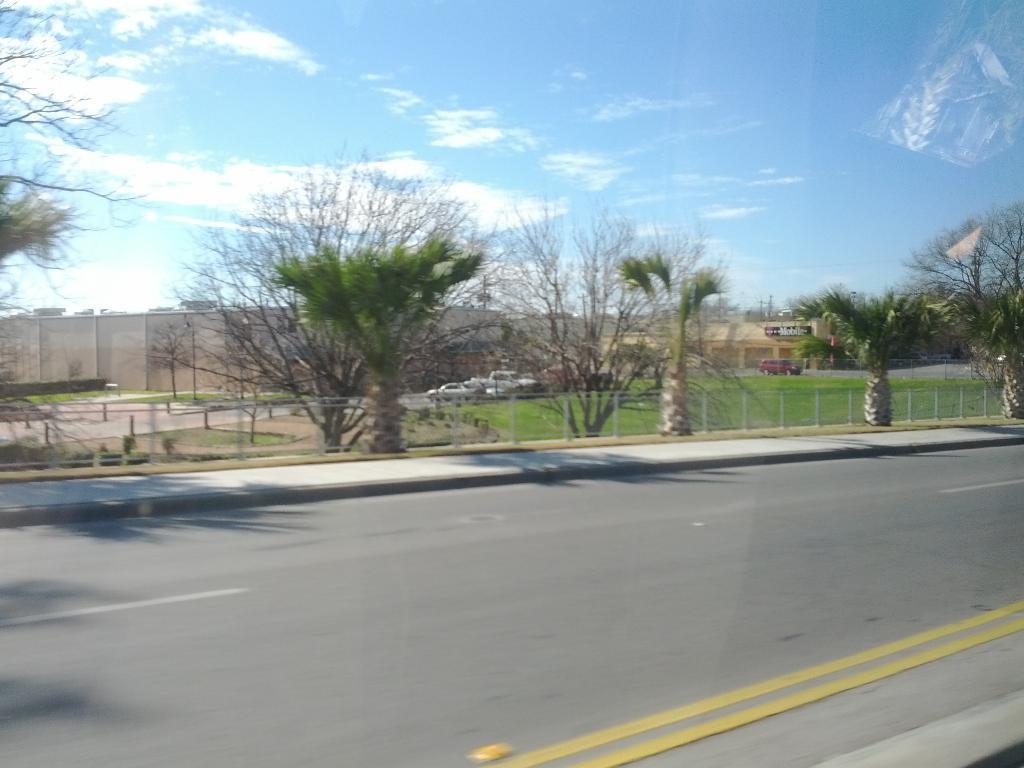Describe this image in one or two sentences. In this image, I can see the trees, cars and buildings. This is the road. This looks like a fence. I think this is a glass door with the reflection of an object. These are the clouds in the sky. 